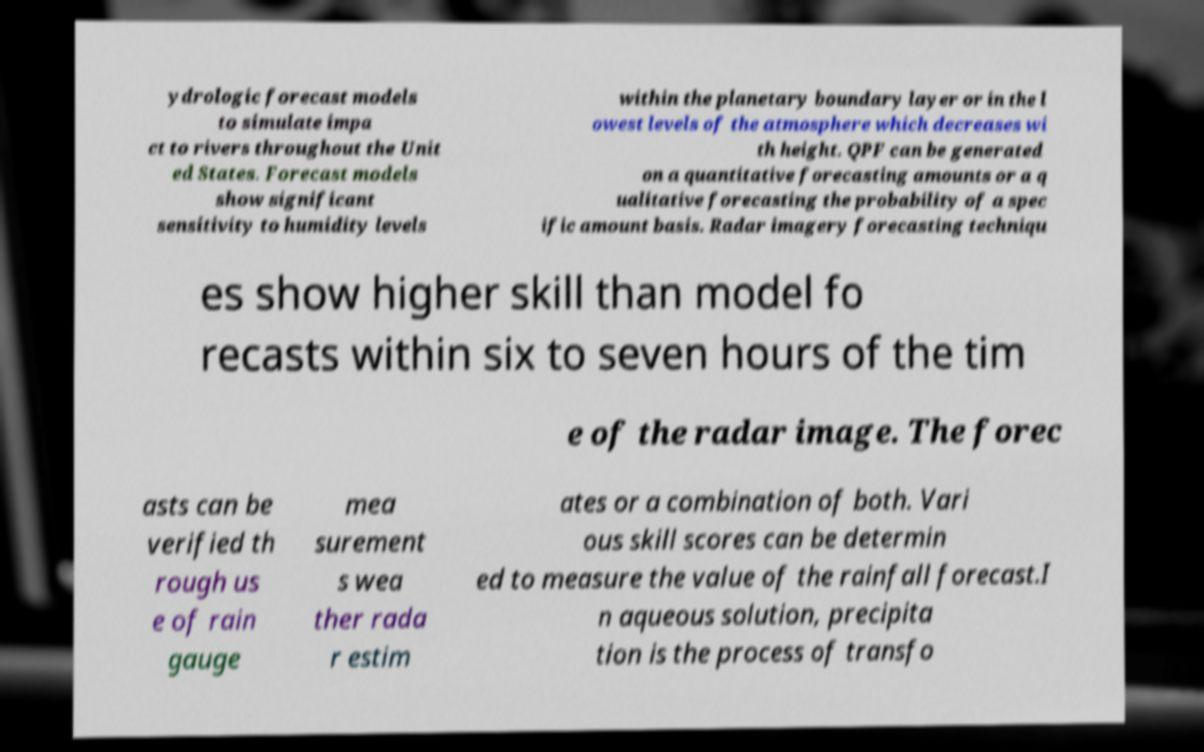Could you assist in decoding the text presented in this image and type it out clearly? ydrologic forecast models to simulate impa ct to rivers throughout the Unit ed States. Forecast models show significant sensitivity to humidity levels within the planetary boundary layer or in the l owest levels of the atmosphere which decreases wi th height. QPF can be generated on a quantitative forecasting amounts or a q ualitative forecasting the probability of a spec ific amount basis. Radar imagery forecasting techniqu es show higher skill than model fo recasts within six to seven hours of the tim e of the radar image. The forec asts can be verified th rough us e of rain gauge mea surement s wea ther rada r estim ates or a combination of both. Vari ous skill scores can be determin ed to measure the value of the rainfall forecast.I n aqueous solution, precipita tion is the process of transfo 